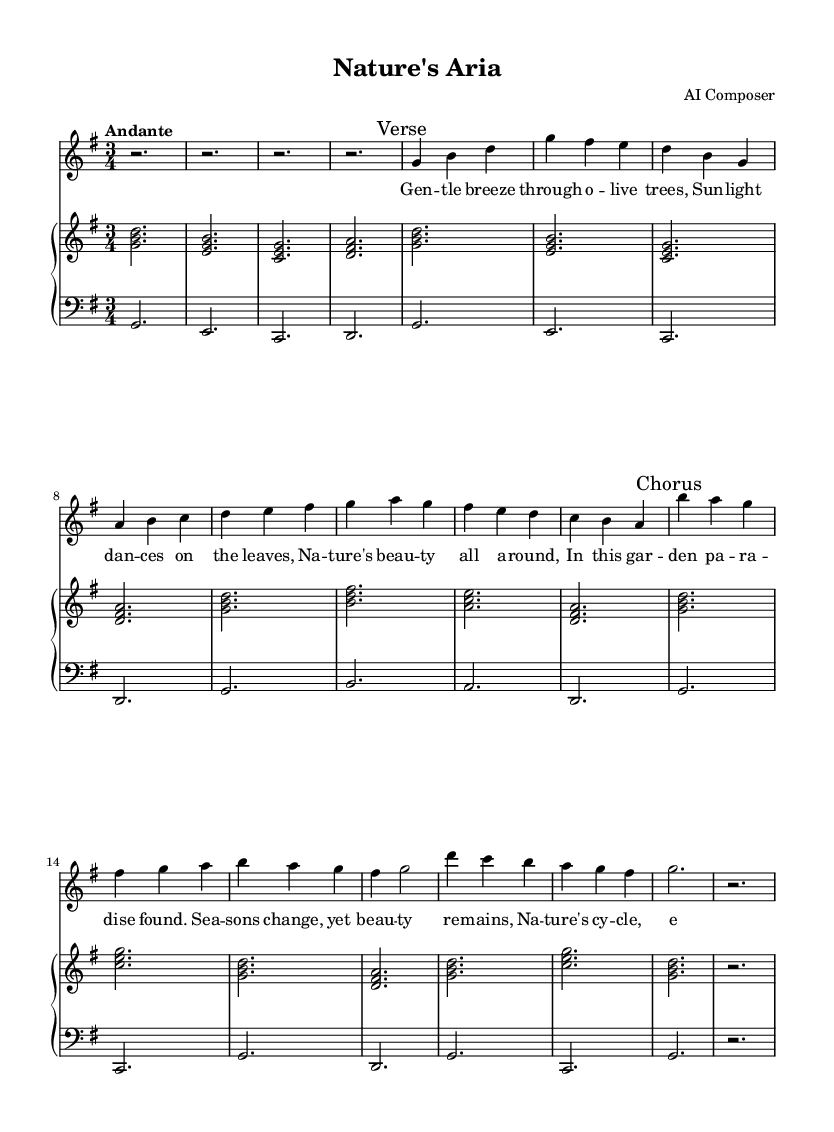What is the key signature of this music? The key signature is G major, which has one sharp (F#). This can be determined by looking at the key signature noted at the beginning of the staff.
Answer: G major What is the time signature of this music? The time signature is 3/4, which indicates that there are three beats in each measure and the quarter note gets one beat. This is shown at the beginning of the sheet music.
Answer: 3/4 What is the tempo indication of this music? The tempo indication is Andante, which suggests a moderately slow pace. This can be seen at the start of the score indicating the desired speed of performance.
Answer: Andante How many measures are there in the verse? There are 8 measures in the verse. This can be counted by examining the number of measure bars (vertical lines) that separate the music notation in the verse section.
Answer: 8 What is the first line of lyrics in the verse? The first line is "Gentle breeze through olive trees." By looking at the lyrics bracketed beneath the soprano line, we can find the words corresponding to the first 8 measures of the music.
Answer: Gentle breeze through olive trees What is the structure of the composition? The structure consists of a verse followed by a chorus. This is indicated by the markings placed in the score, directing the performer on the order of sections.
Answer: Verse and Chorus What is the significance of the changing seasons in the lyrics? The changing seasons highlight the beauty of nature and its cyclical nature, expressing an eternal theme in the art of opera. This reflects the thematic depth often found in opera, connecting personal emotions to the natural world.
Answer: Beauty of nature and its cycles 